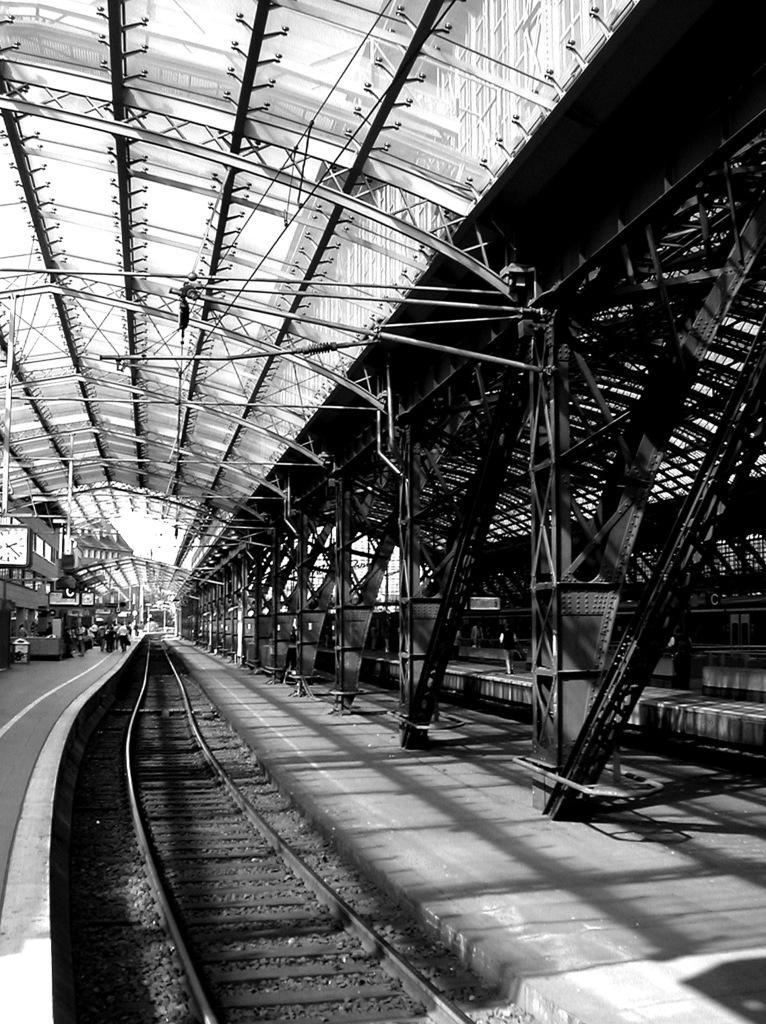Describe this image in one or two sentences. In this picture we can see a railway track and some people on a platform, clock and in the background we can see rods. 